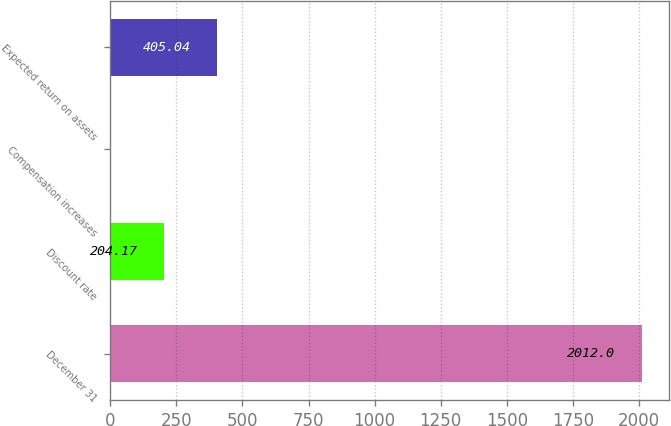Convert chart to OTSL. <chart><loc_0><loc_0><loc_500><loc_500><bar_chart><fcel>December 31<fcel>Discount rate<fcel>Compensation increases<fcel>Expected return on assets<nl><fcel>2012<fcel>204.17<fcel>3.3<fcel>405.04<nl></chart> 